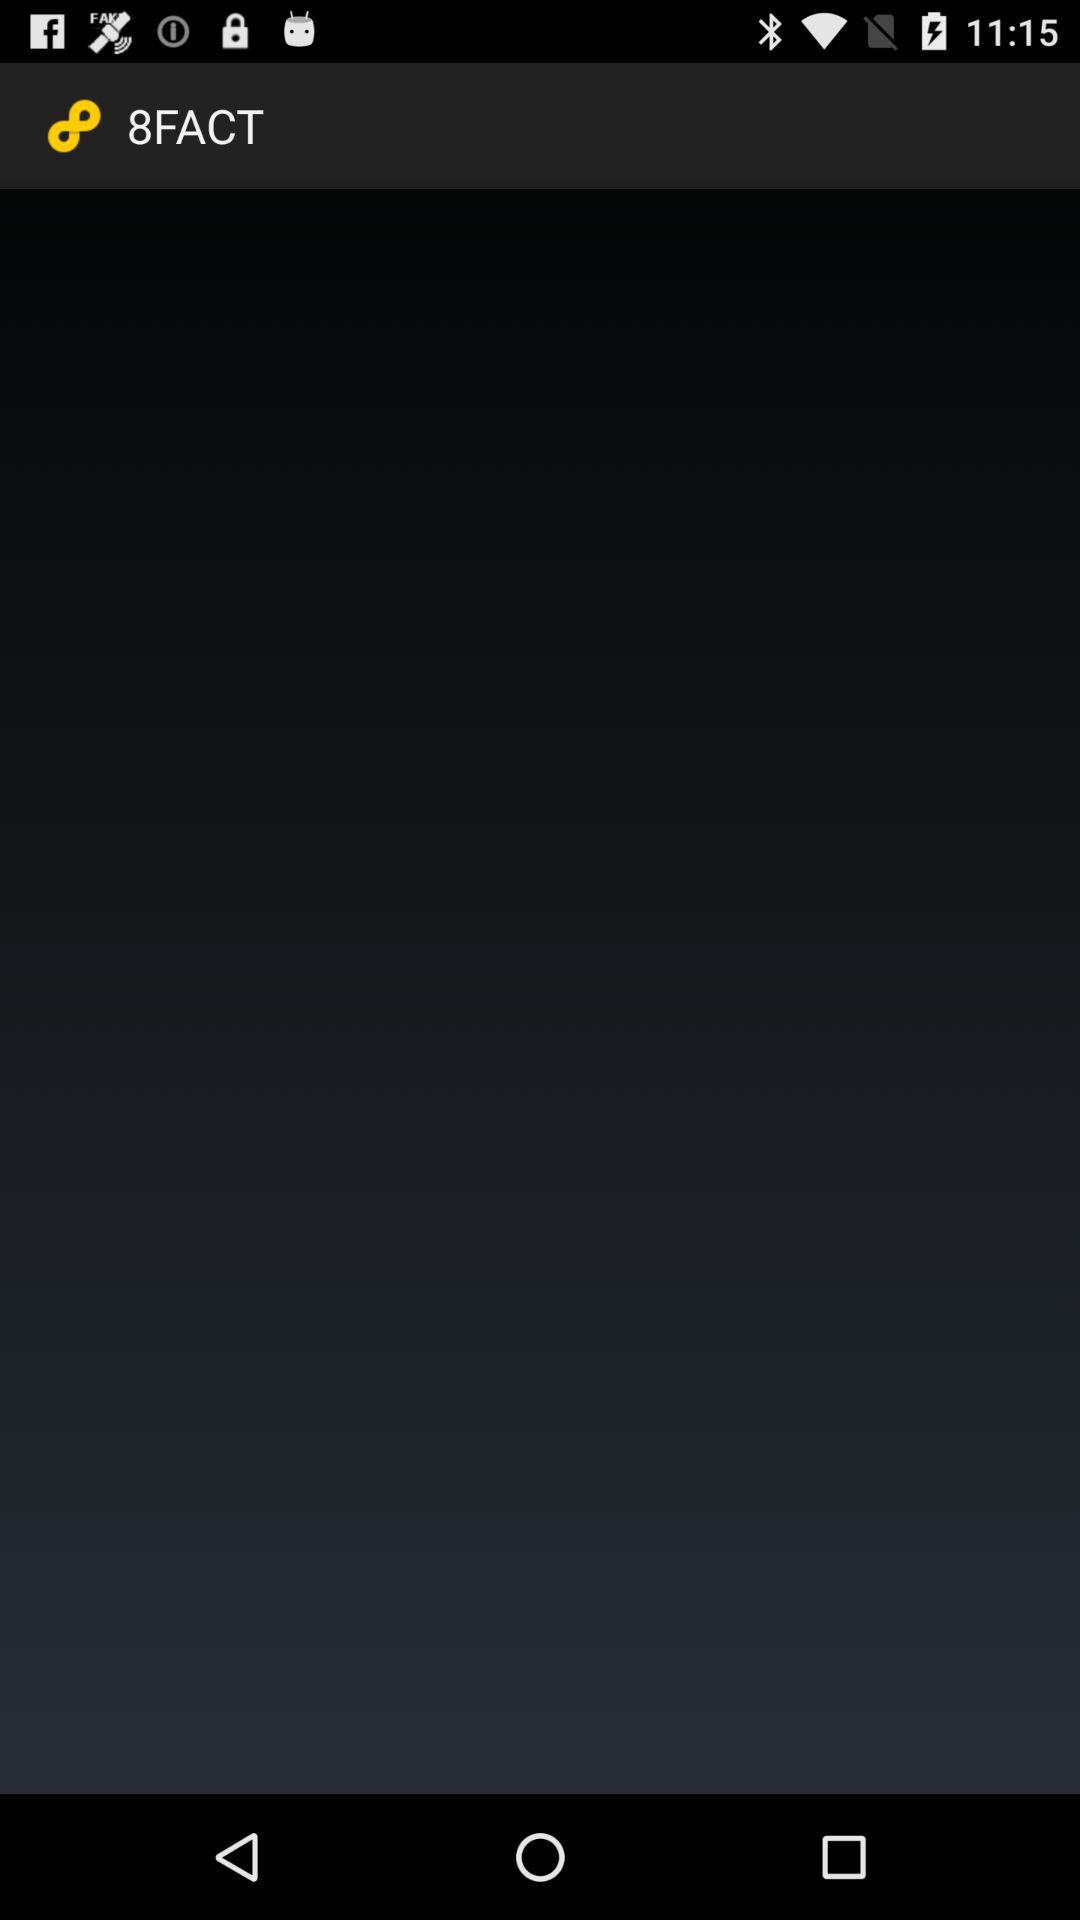What is the name of the application? The name of the application is "8FACT". 